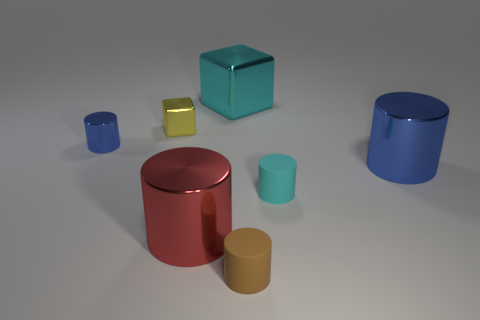Subtract all tiny cyan cylinders. How many cylinders are left? 4 Subtract all cylinders. How many objects are left? 2 Subtract 4 cylinders. How many cylinders are left? 1 Add 3 cylinders. How many objects exist? 10 Subtract all brown cylinders. How many cylinders are left? 4 Subtract all gray balls. How many yellow blocks are left? 1 Subtract all large green metal things. Subtract all red shiny cylinders. How many objects are left? 6 Add 2 cyan metal things. How many cyan metal things are left? 3 Add 4 red things. How many red things exist? 5 Subtract 0 blue balls. How many objects are left? 7 